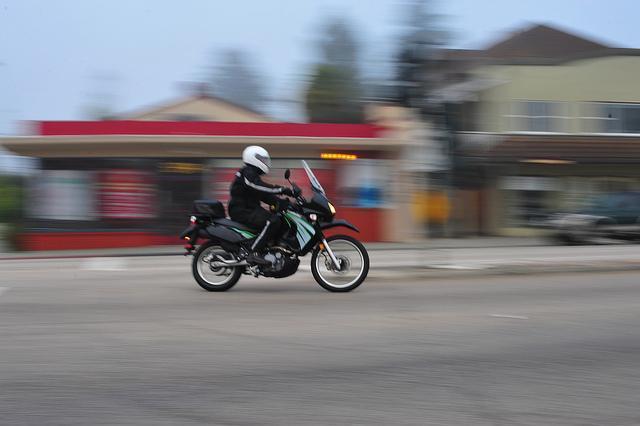How many motorcycles on the road?
Give a very brief answer. 1. 